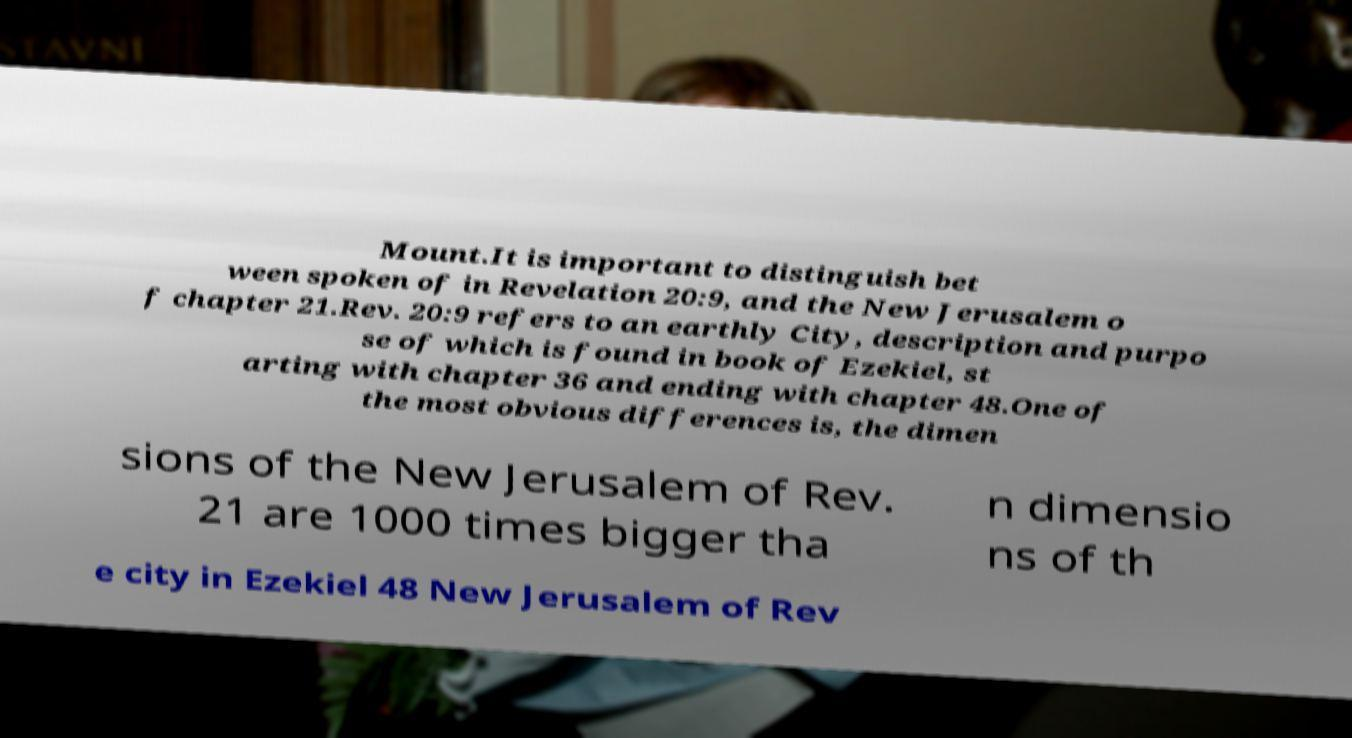For documentation purposes, I need the text within this image transcribed. Could you provide that? Mount.It is important to distinguish bet ween spoken of in Revelation 20:9, and the New Jerusalem o f chapter 21.Rev. 20:9 refers to an earthly City, description and purpo se of which is found in book of Ezekiel, st arting with chapter 36 and ending with chapter 48.One of the most obvious differences is, the dimen sions of the New Jerusalem of Rev. 21 are 1000 times bigger tha n dimensio ns of th e city in Ezekiel 48 New Jerusalem of Rev 